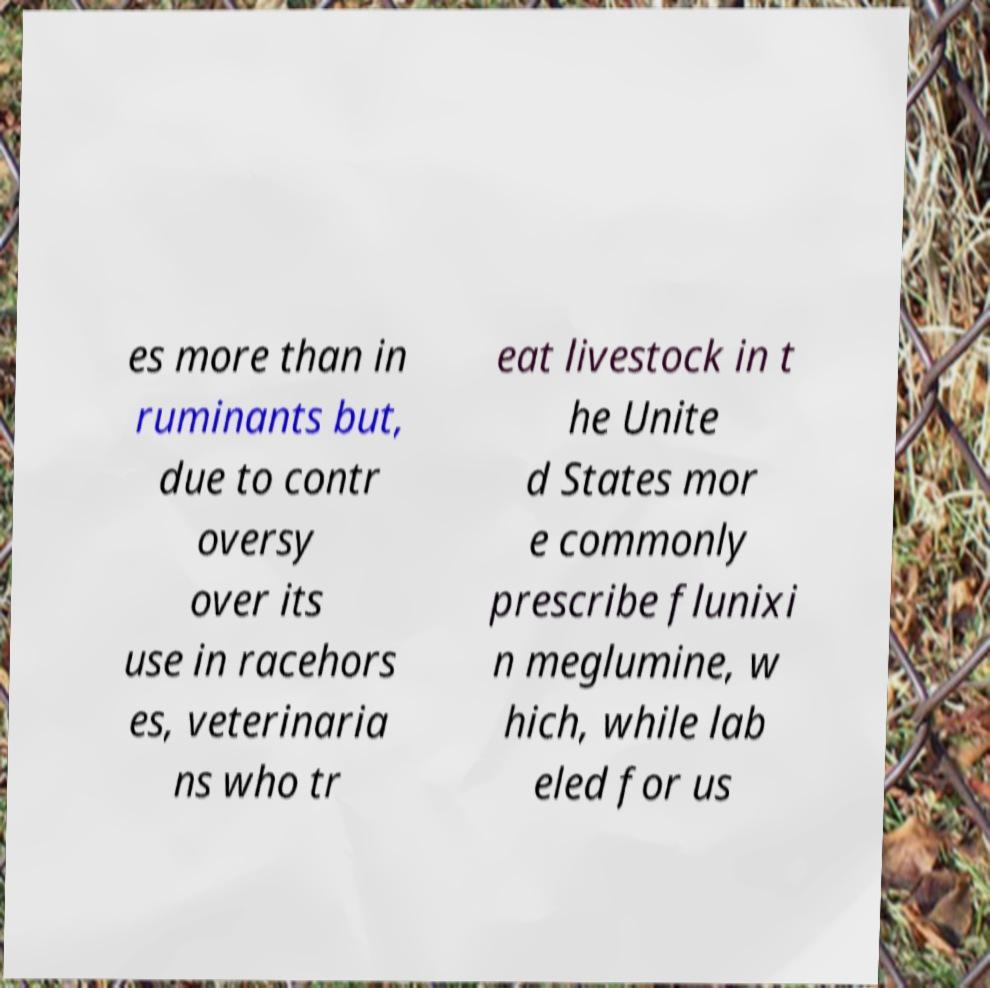Please identify and transcribe the text found in this image. es more than in ruminants but, due to contr oversy over its use in racehors es, veterinaria ns who tr eat livestock in t he Unite d States mor e commonly prescribe flunixi n meglumine, w hich, while lab eled for us 